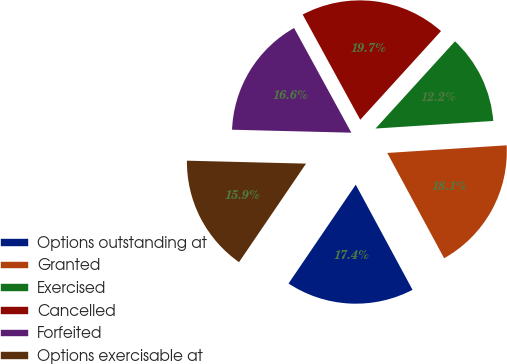Convert chart to OTSL. <chart><loc_0><loc_0><loc_500><loc_500><pie_chart><fcel>Options outstanding at<fcel>Granted<fcel>Exercised<fcel>Cancelled<fcel>Forfeited<fcel>Options exercisable at<nl><fcel>17.39%<fcel>18.14%<fcel>12.22%<fcel>19.73%<fcel>16.64%<fcel>15.89%<nl></chart> 